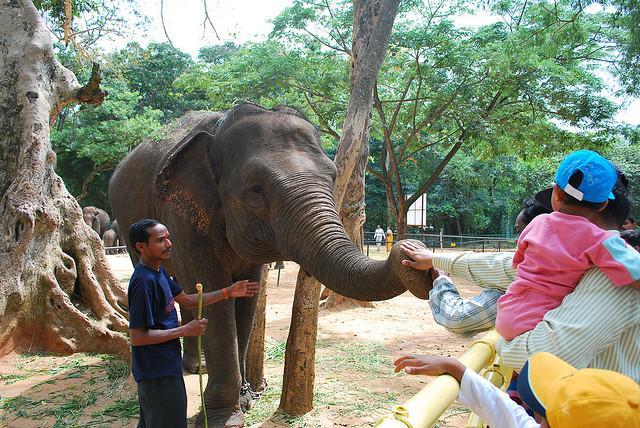What Disney cartoon character is based on this animal? dumbo 